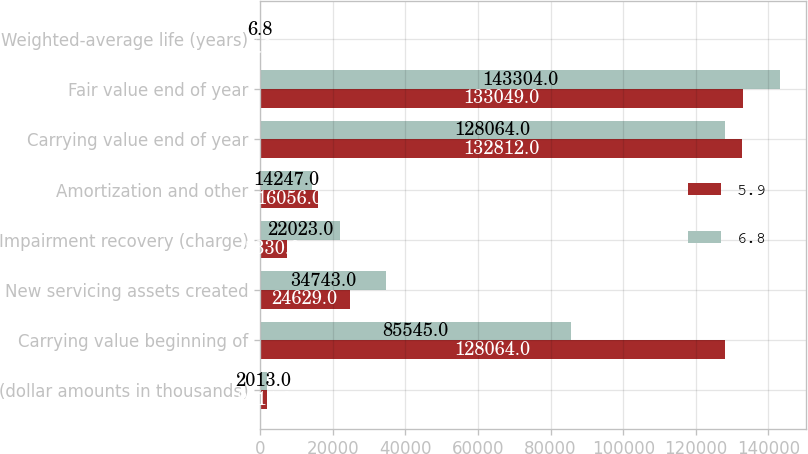Convert chart. <chart><loc_0><loc_0><loc_500><loc_500><stacked_bar_chart><ecel><fcel>(dollar amounts in thousands)<fcel>Carrying value beginning of<fcel>New servicing assets created<fcel>Impairment recovery (charge)<fcel>Amortization and other<fcel>Carrying value end of year<fcel>Fair value end of year<fcel>Weighted-average life (years)<nl><fcel>5.9<fcel>2014<fcel>128064<fcel>24629<fcel>7330<fcel>16056<fcel>132812<fcel>133049<fcel>5.9<nl><fcel>6.8<fcel>2013<fcel>85545<fcel>34743<fcel>22023<fcel>14247<fcel>128064<fcel>143304<fcel>6.8<nl></chart> 